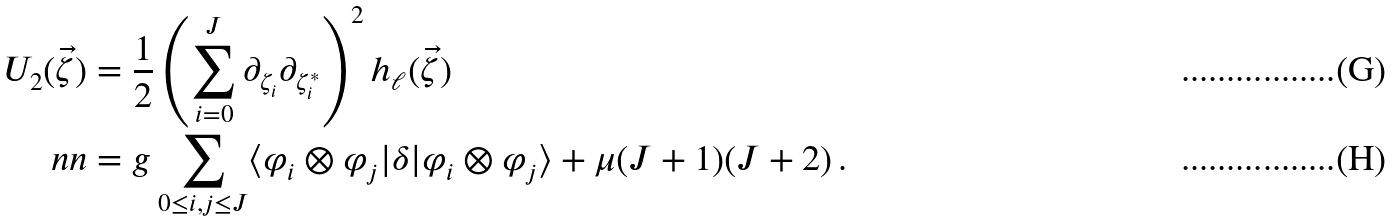<formula> <loc_0><loc_0><loc_500><loc_500>U _ { 2 } ( \vec { \zeta } ) & = \frac { 1 } { 2 } \left ( \sum _ { i = 0 } ^ { J } \partial _ { \zeta _ { i } } \partial _ { \zeta _ { i } ^ { * } } \right ) ^ { 2 } h _ { \ell } ( \vec { \zeta } ) \\ \ n n & = g \sum _ { 0 \leq i , j \leq J } \langle \varphi _ { i } \otimes \varphi _ { j } | \delta | \varphi _ { i } \otimes \varphi _ { j } \rangle + \mu ( J + 1 ) ( J + 2 ) \, .</formula> 